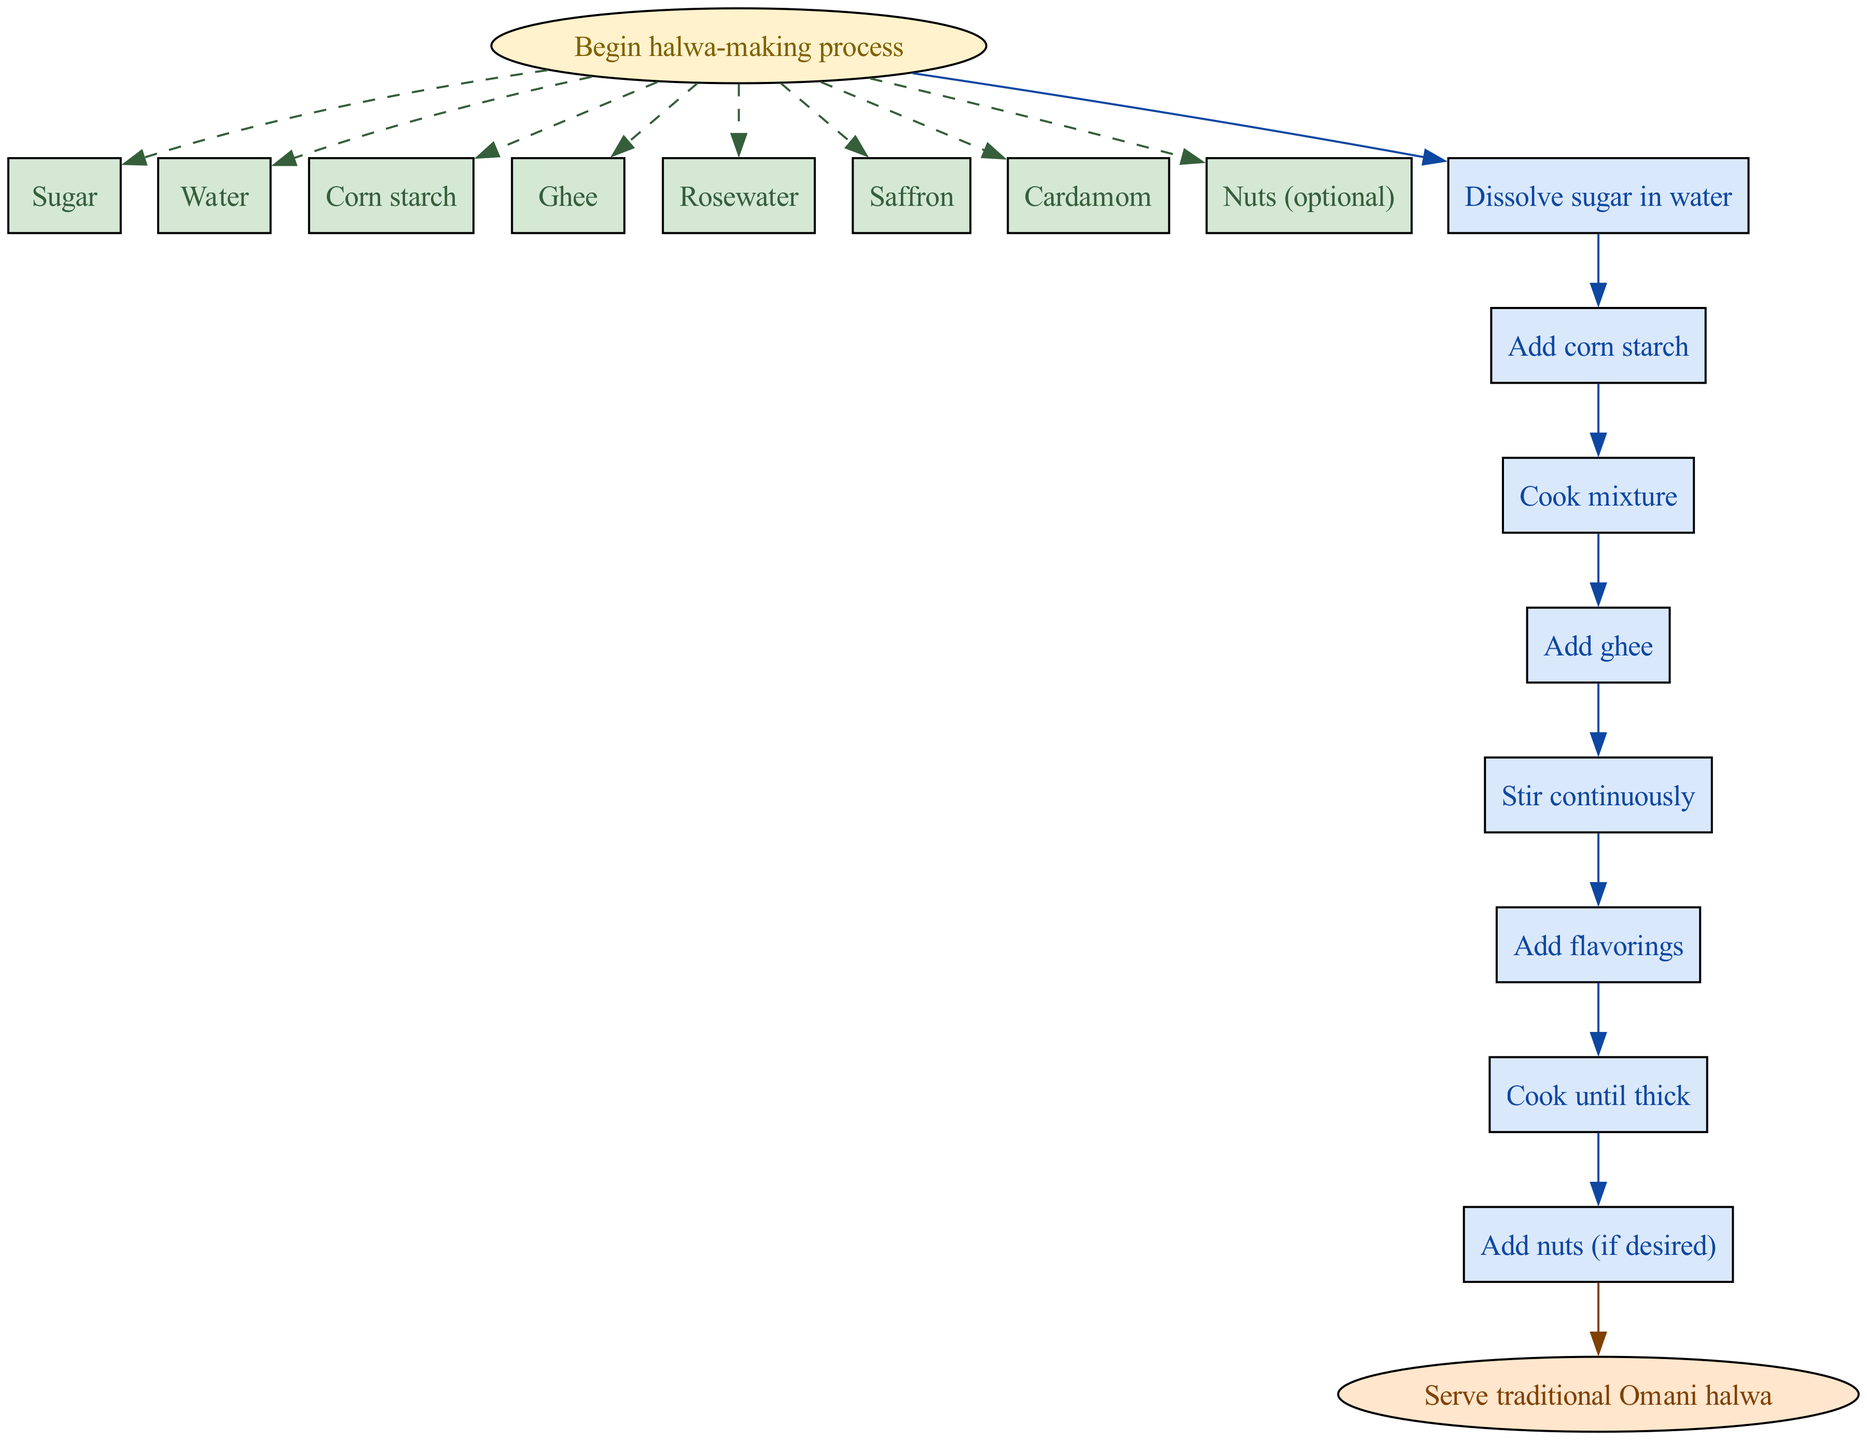What is the first step in making Omani halwa? The diagram starts with the node labeled "Begin halwa-making process," followed by the step "Dissolve sugar in water," indicating that this is the first action to take in the process.
Answer: Dissolve sugar in water How many inputs are needed for the halwa-making process? The diagram lists eight specific ingredients required as inputs from the start node, which can be counted as they are presented in a side subgraph.
Answer: Eight What step comes after "Add corn starch"? The diagram flows sequentially from "Add corn starch" to "Cook mixture," demonstrating the order in which the steps need to be followed.
Answer: Cook mixture Which step includes adding flavorings? The diagram indicates a clear sequence, showing that "Add flavorings" is a step that directly follows "Stir continuously," making it easy to identify the relevant step.
Answer: Add flavorings What is the last action before serving traditional Omani halwa? Following the processing steps, the last node before the endpoint states "Pour into serving dish," indicating that this is the final preparation action to take before serving.
Answer: Pour into serving dish Which optional ingredient can be added before pouring the halwa into the serving dish? The flow chart shows that after reaching "Cook until thick," there is a step labeled "Add nuts (if desired)" indicating that nuts can be added at this stage if one wishes.
Answer: Nuts How does the process end? The flowchart clearly points to an end node labeled "Serve traditional Omani halwa," denoting how the overall process concludes leading to serving.
Answer: Serve traditional Omani halwa What color is used for the process steps in the diagram? Each process step is highlighted with a specific color attribute, and in this diagram, they are filled using a shade of blue, specifically noted as light blue.
Answer: Light blue 